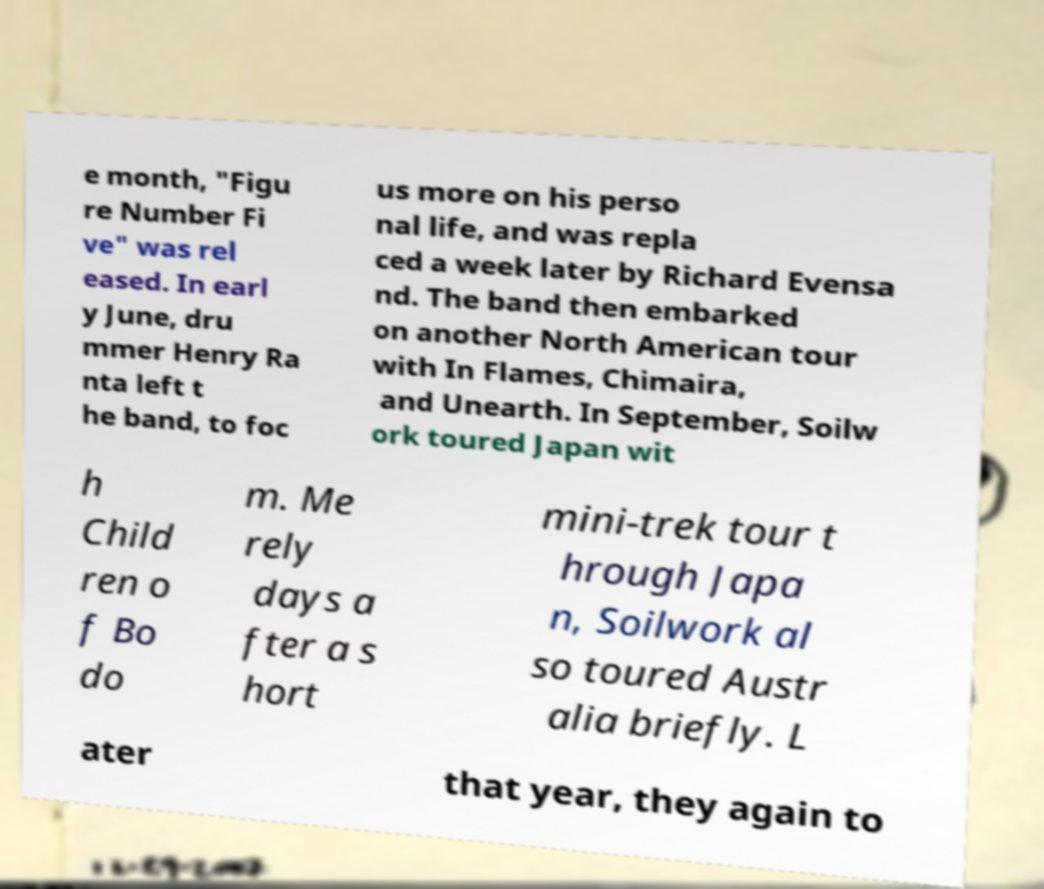Please read and relay the text visible in this image. What does it say? e month, "Figu re Number Fi ve" was rel eased. In earl y June, dru mmer Henry Ra nta left t he band, to foc us more on his perso nal life, and was repla ced a week later by Richard Evensa nd. The band then embarked on another North American tour with In Flames, Chimaira, and Unearth. In September, Soilw ork toured Japan wit h Child ren o f Bo do m. Me rely days a fter a s hort mini-trek tour t hrough Japa n, Soilwork al so toured Austr alia briefly. L ater that year, they again to 